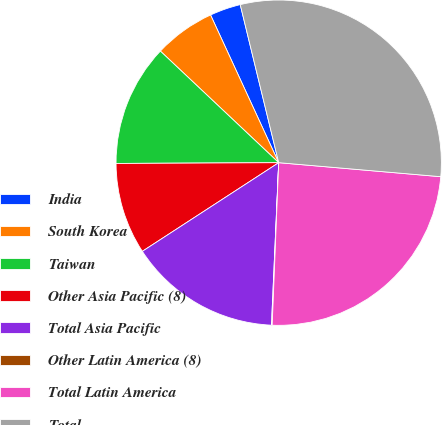Convert chart to OTSL. <chart><loc_0><loc_0><loc_500><loc_500><pie_chart><fcel>India<fcel>South Korea<fcel>Taiwan<fcel>Other Asia Pacific (8)<fcel>Total Asia Pacific<fcel>Other Latin America (8)<fcel>Total Latin America<fcel>Total<nl><fcel>3.08%<fcel>6.09%<fcel>12.11%<fcel>9.1%<fcel>15.12%<fcel>0.07%<fcel>24.27%<fcel>30.18%<nl></chart> 